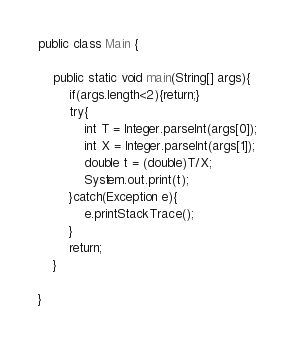Convert code to text. <code><loc_0><loc_0><loc_500><loc_500><_Java_>public class Main {
	
	public static void main(String[] args){
		if(args.length<2){return;}
		try{
			int T = Integer.parseInt(args[0]);
			int X = Integer.parseInt(args[1]);
			double t = (double)T/X;
			System.out.print(t);
		}catch(Exception e){
			e.printStackTrace();
		}
		return;
	}

}
</code> 